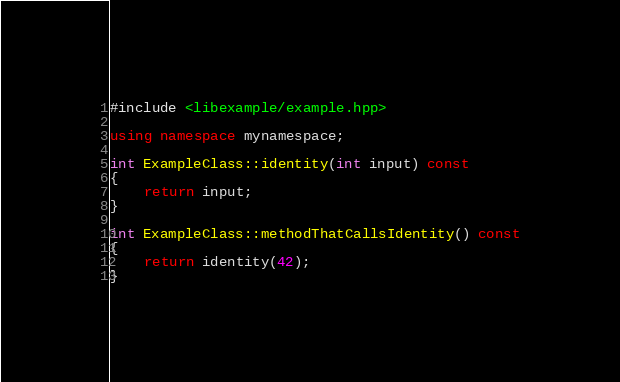<code> <loc_0><loc_0><loc_500><loc_500><_C++_>#include <libexample/example.hpp>

using namespace mynamespace;

int ExampleClass::identity(int input) const
{
    return input;
}

int ExampleClass::methodThatCallsIdentity() const
{
    return identity(42);
}
</code> 